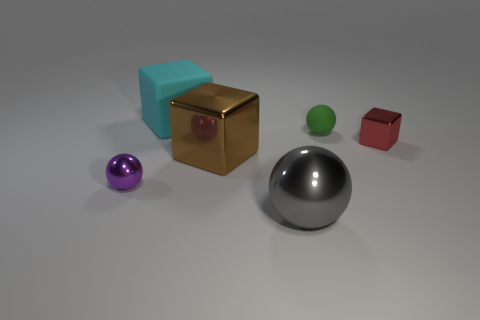Add 2 big rubber cubes. How many objects exist? 8 Add 2 big gray shiny blocks. How many big gray shiny blocks exist? 2 Subtract 0 yellow spheres. How many objects are left? 6 Subtract all big blue objects. Subtract all tiny objects. How many objects are left? 3 Add 3 small purple things. How many small purple things are left? 4 